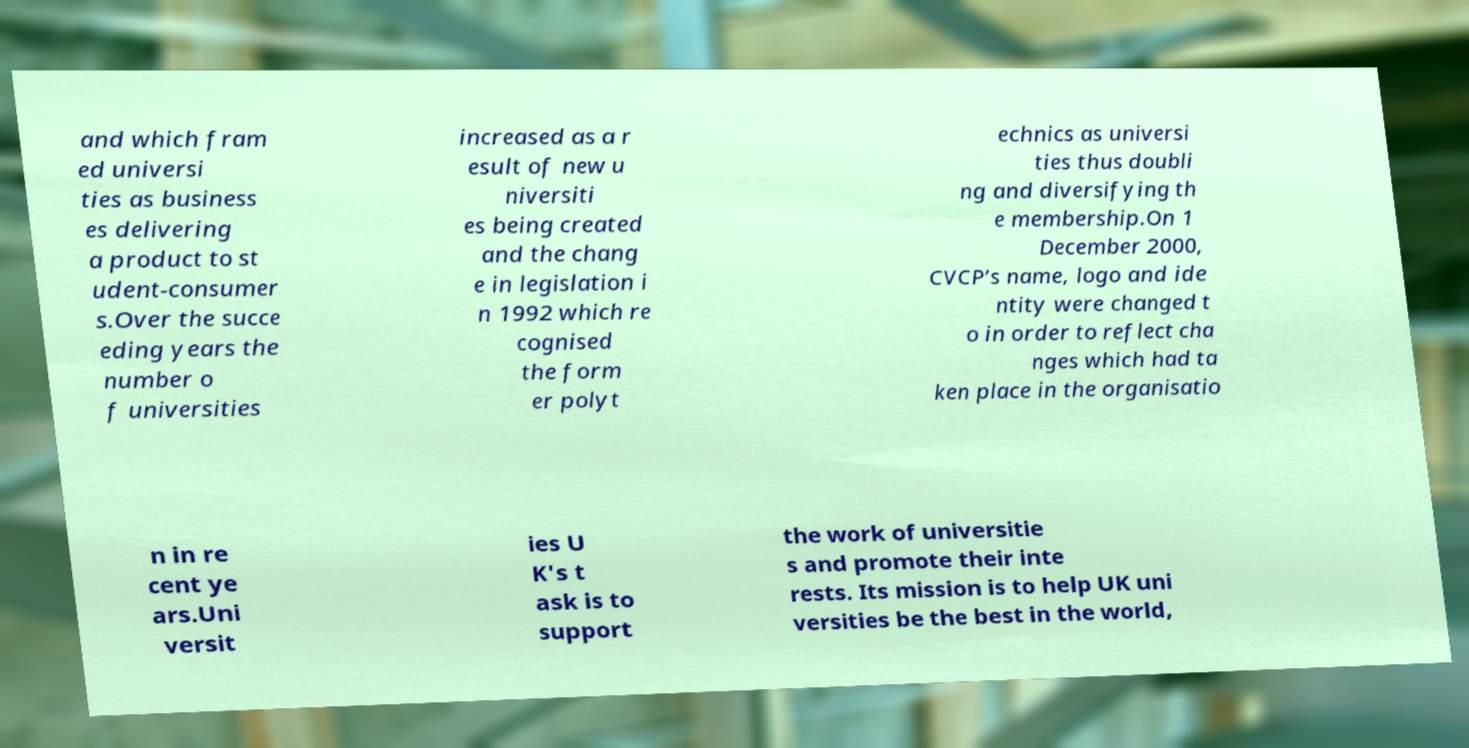What messages or text are displayed in this image? I need them in a readable, typed format. and which fram ed universi ties as business es delivering a product to st udent-consumer s.Over the succe eding years the number o f universities increased as a r esult of new u niversiti es being created and the chang e in legislation i n 1992 which re cognised the form er polyt echnics as universi ties thus doubli ng and diversifying th e membership.On 1 December 2000, CVCP’s name, logo and ide ntity were changed t o in order to reflect cha nges which had ta ken place in the organisatio n in re cent ye ars.Uni versit ies U K's t ask is to support the work of universitie s and promote their inte rests. Its mission is to help UK uni versities be the best in the world, 